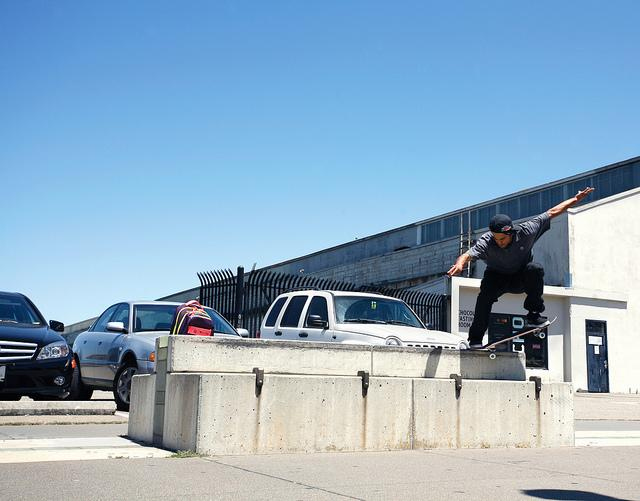What is the man on the board doing on the ledge?

Choices:
A) flipping
B) grinding
C) waxing
D) manualing grinding 